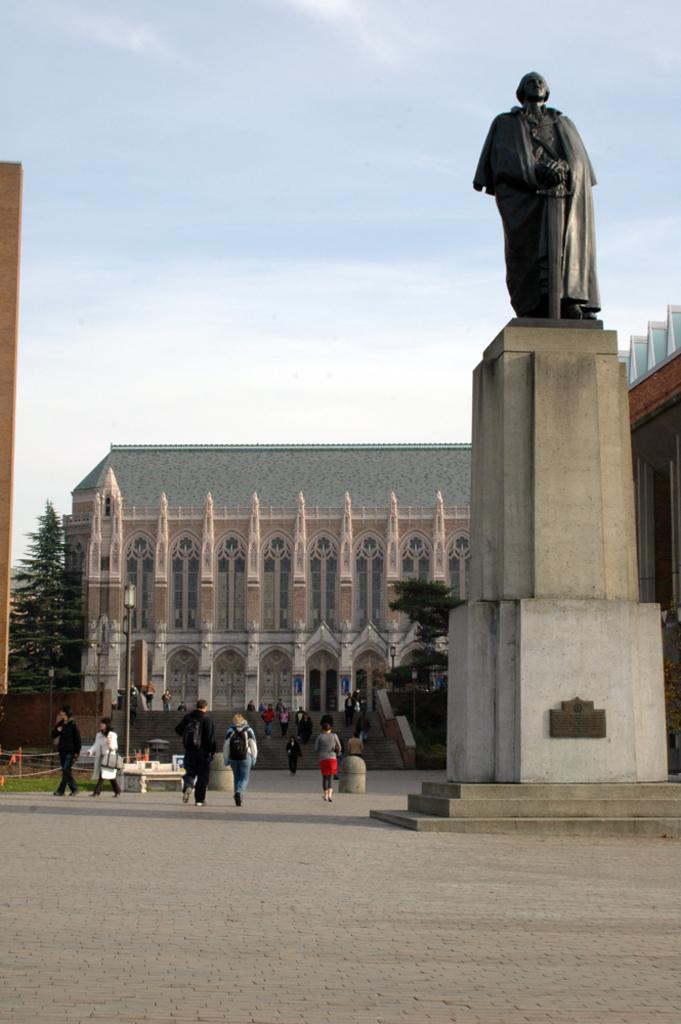What is located on the right side of the image in the foreground? There is a sculpture in the foreground of the image on the right side. What can be seen on the left side of the image? There are persons walking on the pavement on the left side of the image. What is present on the left side of the image besides the persons walking? A light pole is present on the left side of the image. Can you describe any architectural features in the image? Yes, there are stairs and buildings visible in the image. What type of natural elements can be seen in the image? Trees are visible in the image. What is visible in the background of the image? The sky is visible in the image. Can you see any flames coming from the shoe in the image? There is no shoe present in the image, and therefore no flames can be observed. What type of look does the sculpture have in the image? The provided facts do not mention any specific look or expression of the sculpture, so it cannot be determined from the image. 